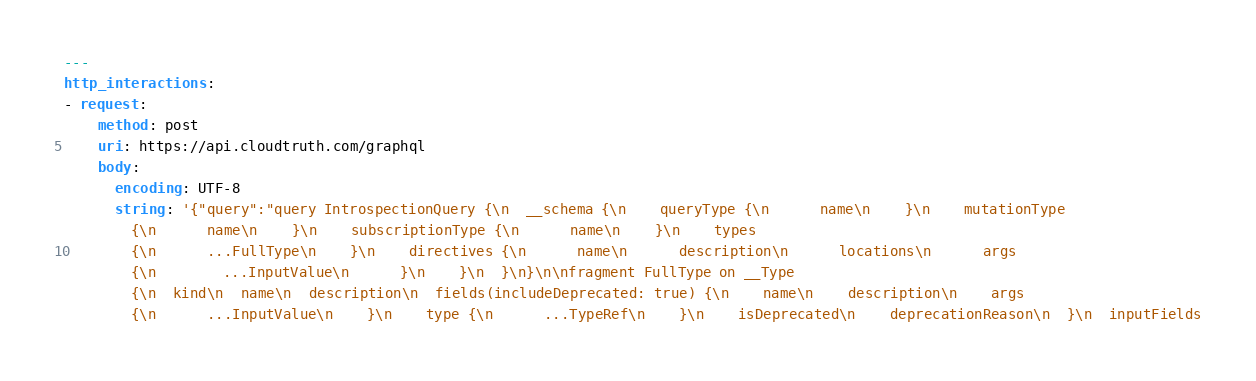Convert code to text. <code><loc_0><loc_0><loc_500><loc_500><_YAML_>---
http_interactions:
- request:
    method: post
    uri: https://api.cloudtruth.com/graphql
    body:
      encoding: UTF-8
      string: '{"query":"query IntrospectionQuery {\n  __schema {\n    queryType {\n      name\n    }\n    mutationType
        {\n      name\n    }\n    subscriptionType {\n      name\n    }\n    types
        {\n      ...FullType\n    }\n    directives {\n      name\n      description\n      locations\n      args
        {\n        ...InputValue\n      }\n    }\n  }\n}\n\nfragment FullType on __Type
        {\n  kind\n  name\n  description\n  fields(includeDeprecated: true) {\n    name\n    description\n    args
        {\n      ...InputValue\n    }\n    type {\n      ...TypeRef\n    }\n    isDeprecated\n    deprecationReason\n  }\n  inputFields</code> 